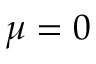Convert formula to latex. <formula><loc_0><loc_0><loc_500><loc_500>\mu = 0</formula> 